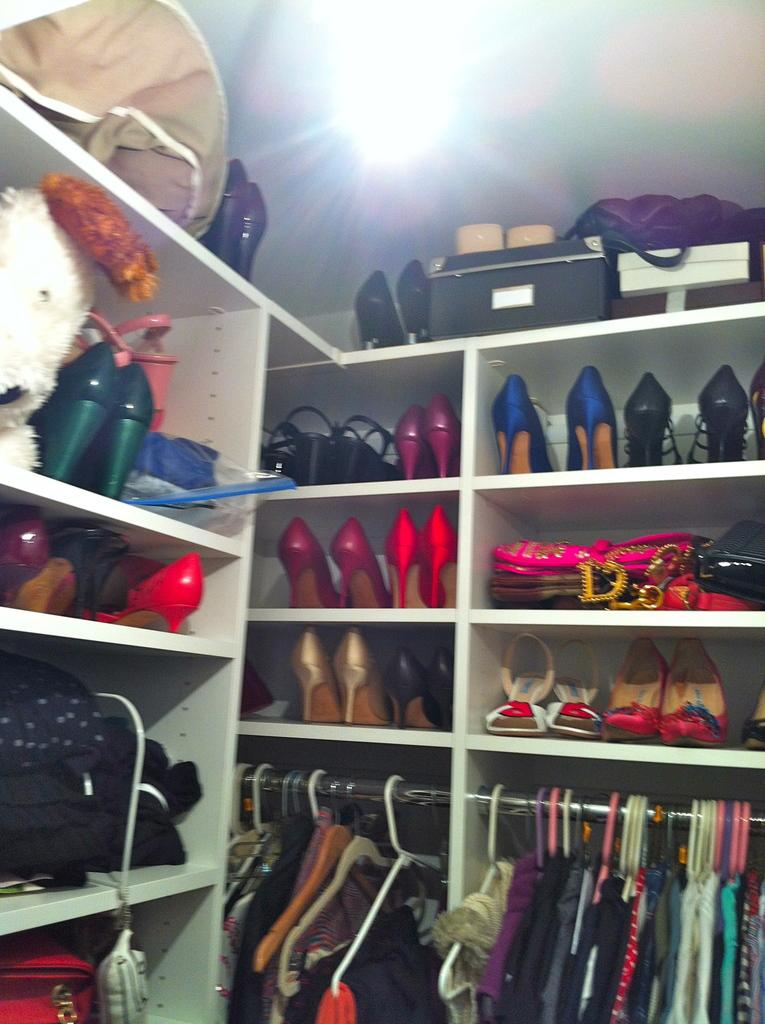What type of footwear is visible in the image? There are slippers in the image. What type of clothing is visible in the image? There are dresses in the image. What type of accessory is visible in the image? There are handbags in the image. What type of storage or display is visible in the image? There are objects arranged in shelves in the image. What time does the cub appear in the image? There is no cub present in the image. How many clocks are visible in the image? There are no clocks visible in the image. 